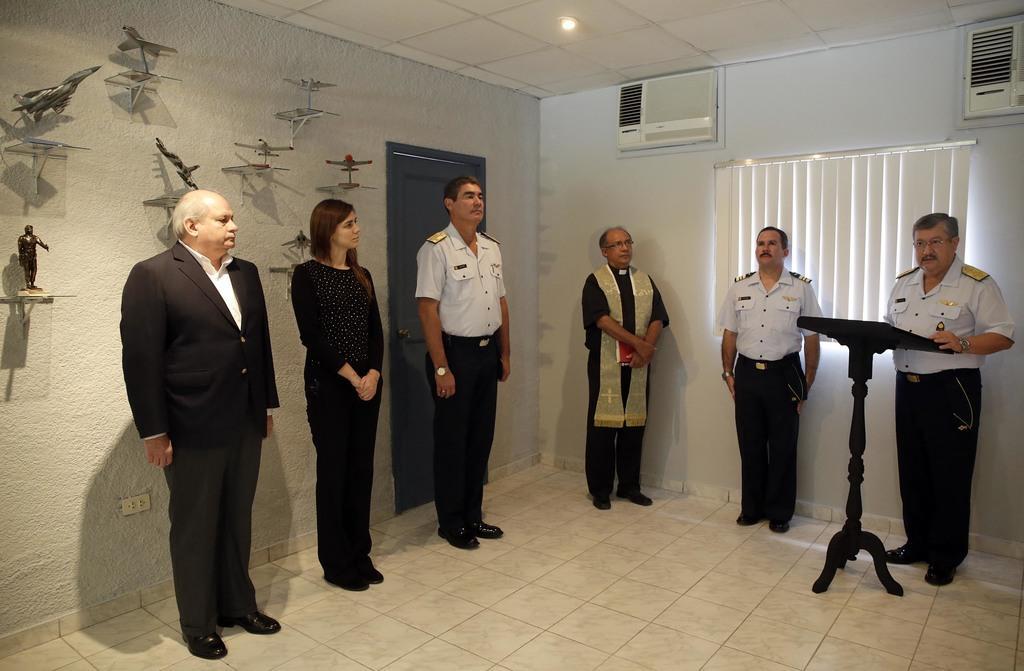Describe this image in one or two sentences. In this image I can see few people are standing. I can see three of them are wearing uniforms and rest all are wearing black colour dress. Here I can see a podium, window blind, air conditioners, a light, a door and on this wall I can see number of things. 